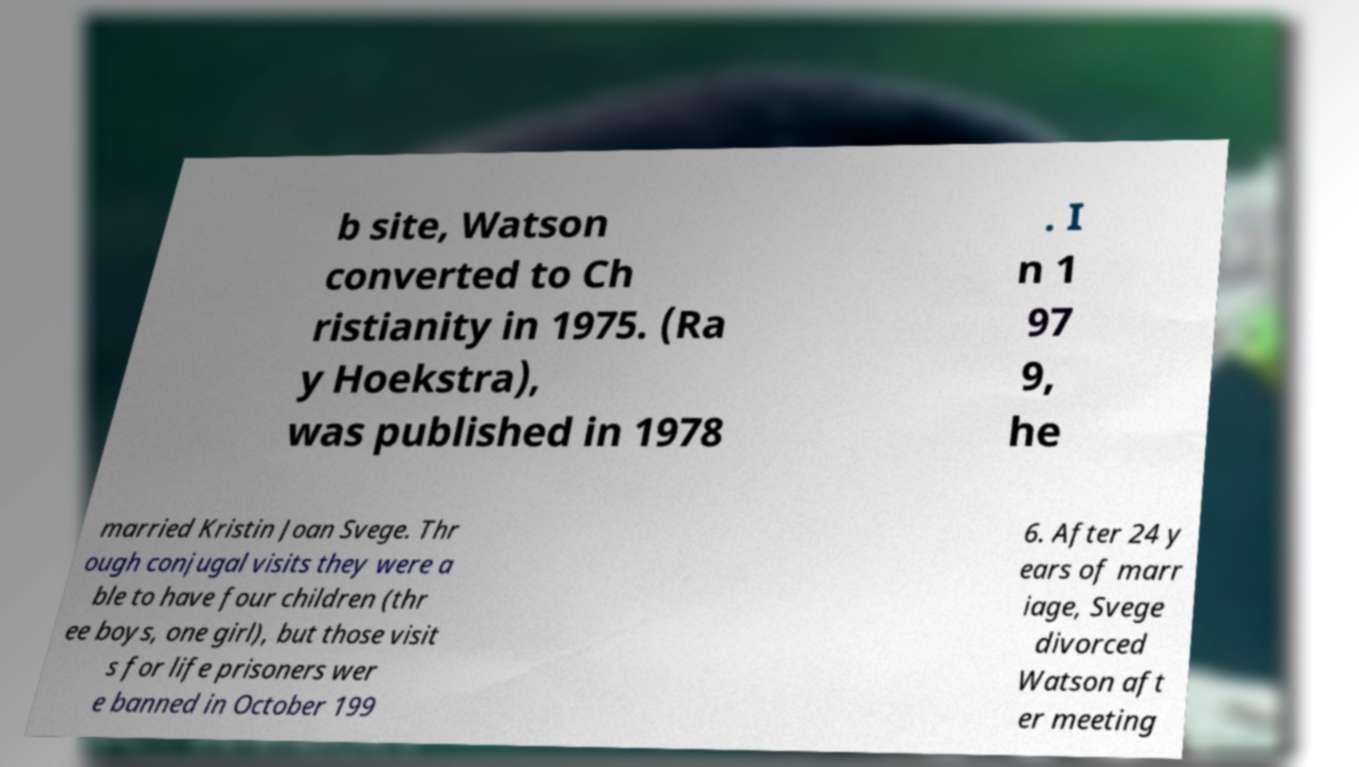Could you assist in decoding the text presented in this image and type it out clearly? b site, Watson converted to Ch ristianity in 1975. (Ra y Hoekstra), was published in 1978 . I n 1 97 9, he married Kristin Joan Svege. Thr ough conjugal visits they were a ble to have four children (thr ee boys, one girl), but those visit s for life prisoners wer e banned in October 199 6. After 24 y ears of marr iage, Svege divorced Watson aft er meeting 